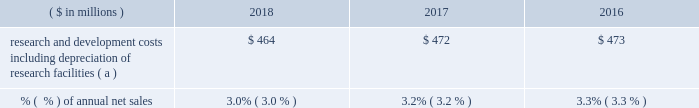18 2018 ppg annual report and 10-k research and development .
( a ) prior year amounts have been recast for the adoption of accounting standards update no .
2017-07 , "improving the presentation of net periodic pension cost and net periodic postretirement benefit cost . 201d see note 1 within item 8 of this form 10-k for additional information .
Technology innovation has been a hallmark of ppg 2019s success throughout its history .
The company seeks to optimize its investment in research and development to create new products to drive profitable growth .
We align our product development with the macro trends in the markets we serve and leverage core technology platforms to develop products for unmet market needs .
Our history of successful technology introductions is based on a commitment to an efficient and effective innovation process and disciplined portfolio management .
We have obtained government funding for a small portion of the company 2019s research efforts , and we will continue to pursue government funding where appropriate .
Ppg owns and operates several facilities to conduct research and development for new and improved products and processes .
In addition to the company 2019s centralized principal research and development centers ( see item 2 .
201cproperties 201d of this form 10-k ) , operating segments manage their development through centers of excellence .
As part of our ongoing efforts to manage our formulations and raw material costs effectively , we operate a global competitive sourcing laboratory in china .
Because of the company 2019s broad array of products and customers , ppg is not materially dependent upon any single technology platform .
Raw materials and energy the effective management of raw materials and energy is important to ppg 2019s continued success .
Ppg uses a wide variety of complex raw materials that serve as the building blocks of our manufactured products that provide broad ranging , high performance solutions to our customers .
The company 2019s most significant raw materials are epoxy and other resins , titanium dioxide and other pigments , and solvents in the coatings businesses and sand and soda ash for the specialty coatings and materials business .
Coatings raw materials include both organic , primarily petroleum-derived , materials and inorganic materials , including titanium dioxide .
These raw materials represent ppg 2019s single largest production cost component .
Most of the raw materials and energy used in production are purchased from outside sources , and the company has made , and plans to continue to make , supply arrangements to meet our planned operating requirements for the future .
Supply of critical raw materials and energy is managed by establishing contracts with multiple sources , and identifying alternative materials or technology whenever possible .
Our products use both petroleum-derived and bio-based materials as part of a product renewal strategy .
While prices for these raw materials typically fluctuate with energy prices and global supply and demand , such fluctuations are impacted by the fact that the manufacture of our raw materials is several steps downstream from crude oil and natural gas .
The company is continuing its aggressive sourcing initiatives to broaden our supply of high quality raw materials .
These initiatives include qualifying multiple and local sources of supply , including suppliers from asia and other lower cost regions of the world , adding on-site resin production at certain manufacturing locations and a reduction in the amount of titanium dioxide used in our product formulations .
We are subject to existing and evolving standards relating to the registration of chemicals which could potentially impact the availability and viability of some of the raw materials we use in our production processes .
Our ongoing , global product stewardship efforts are directed at maintaining our compliance with these standards .
Ppg has joined a global initiative to eliminate child labor from the mica industry , and the company is continuing to take steps , including audits of our suppliers , to ensure compliance with ppg 2019s zero-tolerance policy against the use of child labor in their supply chains .
Changes to chemical registration regulations have been proposed or implemented in the eu and many other countries , including china , canada , the united states ( u.s. ) , brazil , mexico and korea .
Because implementation of many of these programs has not been finalized , the financial impact cannot be estimated at this time .
We anticipate that the number of chemical registration regulations will continue to increase globally , and we have implemented programs to track and comply with these regulations .
Given the recent volatility in certain energy-based input costs and foreign currencies , the company is not able to predict with certainty the 2019 full year impact of related changes in raw material pricing versus 2018 ; however , ppg currently expects overall coatings raw material costs to increase a low-single-digit percentage in the first half of 2019 , with impacts varied by region and commodity .
Further , given the distribution nature of many of our businesses , logistics and distribution costs are sizable , as are wages and benefits but to a lesser degree .
Ppg typically experiences fluctuating prices for energy and raw materials driven by various factors , including changes in supplier feedstock costs and inventories , global industry activity levels , foreign currency exchange rates , government regulation , and global supply and demand factors .
In aggregate , average .
What was the change in millions of research and development costs including depreciation of research facilities from 2017 to 201? 
Computations: (464 - 472)
Answer: -8.0. 